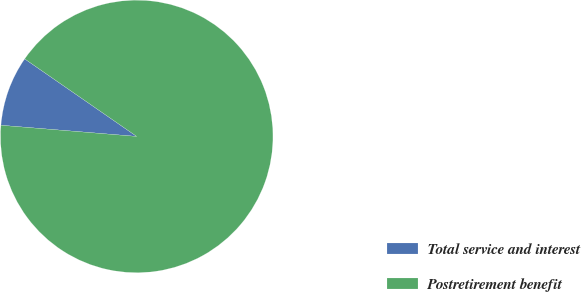Convert chart to OTSL. <chart><loc_0><loc_0><loc_500><loc_500><pie_chart><fcel>Total service and interest<fcel>Postretirement benefit<nl><fcel>8.33%<fcel>91.67%<nl></chart> 